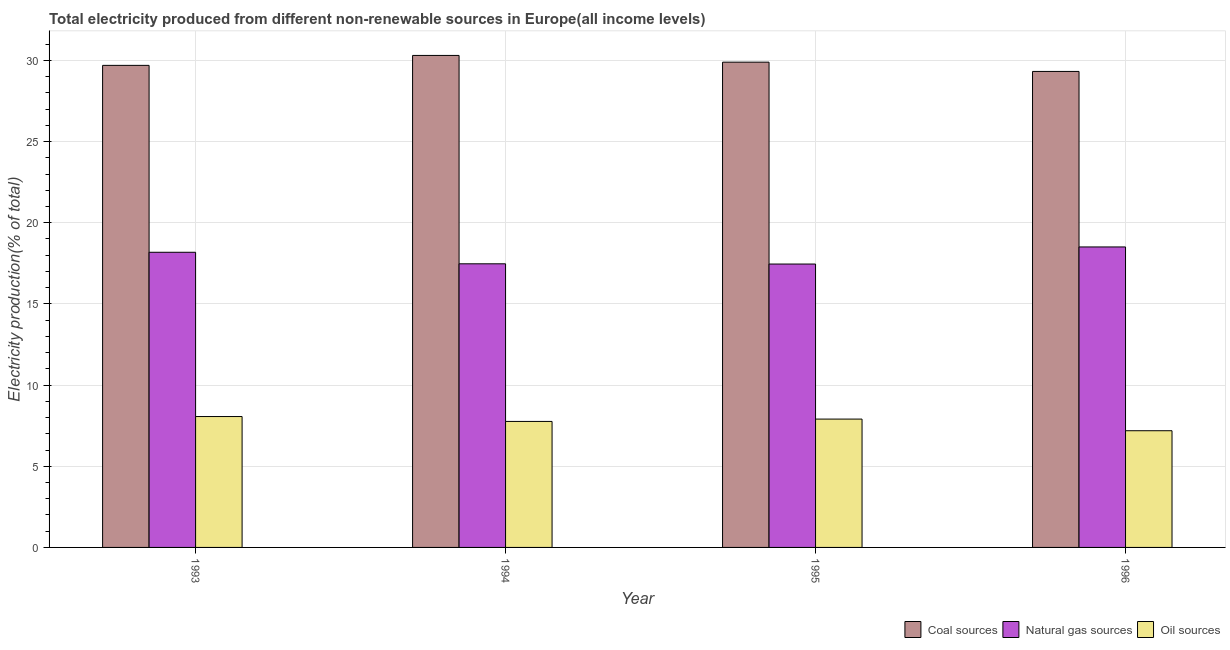How many different coloured bars are there?
Give a very brief answer. 3. How many bars are there on the 2nd tick from the left?
Provide a short and direct response. 3. What is the percentage of electricity produced by coal in 1993?
Keep it short and to the point. 29.7. Across all years, what is the maximum percentage of electricity produced by natural gas?
Offer a terse response. 18.51. Across all years, what is the minimum percentage of electricity produced by oil sources?
Give a very brief answer. 7.19. In which year was the percentage of electricity produced by coal minimum?
Provide a short and direct response. 1996. What is the total percentage of electricity produced by oil sources in the graph?
Your answer should be compact. 30.92. What is the difference between the percentage of electricity produced by oil sources in 1993 and that in 1995?
Give a very brief answer. 0.16. What is the difference between the percentage of electricity produced by natural gas in 1996 and the percentage of electricity produced by coal in 1993?
Provide a succinct answer. 0.33. What is the average percentage of electricity produced by natural gas per year?
Ensure brevity in your answer.  17.9. In the year 1996, what is the difference between the percentage of electricity produced by oil sources and percentage of electricity produced by coal?
Your answer should be very brief. 0. What is the ratio of the percentage of electricity produced by coal in 1994 to that in 1996?
Offer a very short reply. 1.03. What is the difference between the highest and the second highest percentage of electricity produced by oil sources?
Your answer should be very brief. 0.16. What is the difference between the highest and the lowest percentage of electricity produced by oil sources?
Keep it short and to the point. 0.87. What does the 1st bar from the left in 1996 represents?
Ensure brevity in your answer.  Coal sources. What does the 2nd bar from the right in 1996 represents?
Your answer should be very brief. Natural gas sources. How many bars are there?
Your response must be concise. 12. What is the difference between two consecutive major ticks on the Y-axis?
Your response must be concise. 5. Does the graph contain any zero values?
Your answer should be compact. No. Where does the legend appear in the graph?
Offer a terse response. Bottom right. What is the title of the graph?
Ensure brevity in your answer.  Total electricity produced from different non-renewable sources in Europe(all income levels). What is the label or title of the Y-axis?
Provide a succinct answer. Electricity production(% of total). What is the Electricity production(% of total) in Coal sources in 1993?
Give a very brief answer. 29.7. What is the Electricity production(% of total) of Natural gas sources in 1993?
Provide a short and direct response. 18.18. What is the Electricity production(% of total) of Oil sources in 1993?
Your answer should be very brief. 8.06. What is the Electricity production(% of total) of Coal sources in 1994?
Ensure brevity in your answer.  30.31. What is the Electricity production(% of total) of Natural gas sources in 1994?
Your response must be concise. 17.47. What is the Electricity production(% of total) in Oil sources in 1994?
Offer a very short reply. 7.76. What is the Electricity production(% of total) in Coal sources in 1995?
Ensure brevity in your answer.  29.89. What is the Electricity production(% of total) of Natural gas sources in 1995?
Provide a short and direct response. 17.46. What is the Electricity production(% of total) of Oil sources in 1995?
Make the answer very short. 7.91. What is the Electricity production(% of total) of Coal sources in 1996?
Keep it short and to the point. 29.32. What is the Electricity production(% of total) of Natural gas sources in 1996?
Offer a very short reply. 18.51. What is the Electricity production(% of total) of Oil sources in 1996?
Provide a succinct answer. 7.19. Across all years, what is the maximum Electricity production(% of total) of Coal sources?
Offer a terse response. 30.31. Across all years, what is the maximum Electricity production(% of total) of Natural gas sources?
Ensure brevity in your answer.  18.51. Across all years, what is the maximum Electricity production(% of total) in Oil sources?
Give a very brief answer. 8.06. Across all years, what is the minimum Electricity production(% of total) in Coal sources?
Offer a very short reply. 29.32. Across all years, what is the minimum Electricity production(% of total) in Natural gas sources?
Your answer should be very brief. 17.46. Across all years, what is the minimum Electricity production(% of total) of Oil sources?
Provide a succinct answer. 7.19. What is the total Electricity production(% of total) in Coal sources in the graph?
Make the answer very short. 119.22. What is the total Electricity production(% of total) of Natural gas sources in the graph?
Provide a short and direct response. 71.62. What is the total Electricity production(% of total) of Oil sources in the graph?
Ensure brevity in your answer.  30.92. What is the difference between the Electricity production(% of total) in Coal sources in 1993 and that in 1994?
Keep it short and to the point. -0.61. What is the difference between the Electricity production(% of total) in Natural gas sources in 1993 and that in 1994?
Provide a short and direct response. 0.71. What is the difference between the Electricity production(% of total) of Oil sources in 1993 and that in 1994?
Provide a short and direct response. 0.3. What is the difference between the Electricity production(% of total) of Coal sources in 1993 and that in 1995?
Make the answer very short. -0.2. What is the difference between the Electricity production(% of total) of Natural gas sources in 1993 and that in 1995?
Offer a terse response. 0.72. What is the difference between the Electricity production(% of total) in Oil sources in 1993 and that in 1995?
Ensure brevity in your answer.  0.16. What is the difference between the Electricity production(% of total) in Coal sources in 1993 and that in 1996?
Provide a succinct answer. 0.37. What is the difference between the Electricity production(% of total) in Natural gas sources in 1993 and that in 1996?
Give a very brief answer. -0.33. What is the difference between the Electricity production(% of total) in Oil sources in 1993 and that in 1996?
Ensure brevity in your answer.  0.87. What is the difference between the Electricity production(% of total) in Coal sources in 1994 and that in 1995?
Provide a succinct answer. 0.41. What is the difference between the Electricity production(% of total) of Natural gas sources in 1994 and that in 1995?
Ensure brevity in your answer.  0.01. What is the difference between the Electricity production(% of total) of Oil sources in 1994 and that in 1995?
Your response must be concise. -0.14. What is the difference between the Electricity production(% of total) in Coal sources in 1994 and that in 1996?
Your answer should be compact. 0.99. What is the difference between the Electricity production(% of total) of Natural gas sources in 1994 and that in 1996?
Your response must be concise. -1.04. What is the difference between the Electricity production(% of total) of Oil sources in 1994 and that in 1996?
Keep it short and to the point. 0.57. What is the difference between the Electricity production(% of total) of Coal sources in 1995 and that in 1996?
Provide a succinct answer. 0.57. What is the difference between the Electricity production(% of total) in Natural gas sources in 1995 and that in 1996?
Your response must be concise. -1.05. What is the difference between the Electricity production(% of total) in Oil sources in 1995 and that in 1996?
Keep it short and to the point. 0.72. What is the difference between the Electricity production(% of total) in Coal sources in 1993 and the Electricity production(% of total) in Natural gas sources in 1994?
Provide a short and direct response. 12.22. What is the difference between the Electricity production(% of total) of Coal sources in 1993 and the Electricity production(% of total) of Oil sources in 1994?
Give a very brief answer. 21.93. What is the difference between the Electricity production(% of total) in Natural gas sources in 1993 and the Electricity production(% of total) in Oil sources in 1994?
Provide a short and direct response. 10.42. What is the difference between the Electricity production(% of total) in Coal sources in 1993 and the Electricity production(% of total) in Natural gas sources in 1995?
Make the answer very short. 12.24. What is the difference between the Electricity production(% of total) of Coal sources in 1993 and the Electricity production(% of total) of Oil sources in 1995?
Your answer should be very brief. 21.79. What is the difference between the Electricity production(% of total) of Natural gas sources in 1993 and the Electricity production(% of total) of Oil sources in 1995?
Provide a short and direct response. 10.28. What is the difference between the Electricity production(% of total) in Coal sources in 1993 and the Electricity production(% of total) in Natural gas sources in 1996?
Your answer should be compact. 11.19. What is the difference between the Electricity production(% of total) of Coal sources in 1993 and the Electricity production(% of total) of Oil sources in 1996?
Provide a succinct answer. 22.51. What is the difference between the Electricity production(% of total) in Natural gas sources in 1993 and the Electricity production(% of total) in Oil sources in 1996?
Provide a short and direct response. 10.99. What is the difference between the Electricity production(% of total) of Coal sources in 1994 and the Electricity production(% of total) of Natural gas sources in 1995?
Offer a terse response. 12.85. What is the difference between the Electricity production(% of total) in Coal sources in 1994 and the Electricity production(% of total) in Oil sources in 1995?
Keep it short and to the point. 22.4. What is the difference between the Electricity production(% of total) of Natural gas sources in 1994 and the Electricity production(% of total) of Oil sources in 1995?
Offer a very short reply. 9.56. What is the difference between the Electricity production(% of total) in Coal sources in 1994 and the Electricity production(% of total) in Natural gas sources in 1996?
Provide a succinct answer. 11.8. What is the difference between the Electricity production(% of total) in Coal sources in 1994 and the Electricity production(% of total) in Oil sources in 1996?
Provide a short and direct response. 23.12. What is the difference between the Electricity production(% of total) in Natural gas sources in 1994 and the Electricity production(% of total) in Oil sources in 1996?
Offer a terse response. 10.28. What is the difference between the Electricity production(% of total) in Coal sources in 1995 and the Electricity production(% of total) in Natural gas sources in 1996?
Keep it short and to the point. 11.38. What is the difference between the Electricity production(% of total) of Coal sources in 1995 and the Electricity production(% of total) of Oil sources in 1996?
Provide a short and direct response. 22.7. What is the difference between the Electricity production(% of total) in Natural gas sources in 1995 and the Electricity production(% of total) in Oil sources in 1996?
Your answer should be very brief. 10.27. What is the average Electricity production(% of total) in Coal sources per year?
Keep it short and to the point. 29.8. What is the average Electricity production(% of total) in Natural gas sources per year?
Your answer should be very brief. 17.91. What is the average Electricity production(% of total) in Oil sources per year?
Offer a very short reply. 7.73. In the year 1993, what is the difference between the Electricity production(% of total) of Coal sources and Electricity production(% of total) of Natural gas sources?
Provide a succinct answer. 11.51. In the year 1993, what is the difference between the Electricity production(% of total) of Coal sources and Electricity production(% of total) of Oil sources?
Your response must be concise. 21.63. In the year 1993, what is the difference between the Electricity production(% of total) in Natural gas sources and Electricity production(% of total) in Oil sources?
Provide a short and direct response. 10.12. In the year 1994, what is the difference between the Electricity production(% of total) in Coal sources and Electricity production(% of total) in Natural gas sources?
Your answer should be compact. 12.84. In the year 1994, what is the difference between the Electricity production(% of total) of Coal sources and Electricity production(% of total) of Oil sources?
Keep it short and to the point. 22.55. In the year 1994, what is the difference between the Electricity production(% of total) in Natural gas sources and Electricity production(% of total) in Oil sources?
Your answer should be compact. 9.71. In the year 1995, what is the difference between the Electricity production(% of total) in Coal sources and Electricity production(% of total) in Natural gas sources?
Ensure brevity in your answer.  12.44. In the year 1995, what is the difference between the Electricity production(% of total) in Coal sources and Electricity production(% of total) in Oil sources?
Give a very brief answer. 21.99. In the year 1995, what is the difference between the Electricity production(% of total) of Natural gas sources and Electricity production(% of total) of Oil sources?
Make the answer very short. 9.55. In the year 1996, what is the difference between the Electricity production(% of total) in Coal sources and Electricity production(% of total) in Natural gas sources?
Provide a short and direct response. 10.81. In the year 1996, what is the difference between the Electricity production(% of total) in Coal sources and Electricity production(% of total) in Oil sources?
Make the answer very short. 22.13. In the year 1996, what is the difference between the Electricity production(% of total) in Natural gas sources and Electricity production(% of total) in Oil sources?
Make the answer very short. 11.32. What is the ratio of the Electricity production(% of total) in Coal sources in 1993 to that in 1994?
Offer a very short reply. 0.98. What is the ratio of the Electricity production(% of total) of Natural gas sources in 1993 to that in 1994?
Offer a terse response. 1.04. What is the ratio of the Electricity production(% of total) of Oil sources in 1993 to that in 1994?
Offer a very short reply. 1.04. What is the ratio of the Electricity production(% of total) in Coal sources in 1993 to that in 1995?
Offer a terse response. 0.99. What is the ratio of the Electricity production(% of total) in Natural gas sources in 1993 to that in 1995?
Provide a succinct answer. 1.04. What is the ratio of the Electricity production(% of total) of Oil sources in 1993 to that in 1995?
Offer a very short reply. 1.02. What is the ratio of the Electricity production(% of total) in Coal sources in 1993 to that in 1996?
Provide a succinct answer. 1.01. What is the ratio of the Electricity production(% of total) of Natural gas sources in 1993 to that in 1996?
Provide a short and direct response. 0.98. What is the ratio of the Electricity production(% of total) of Oil sources in 1993 to that in 1996?
Provide a short and direct response. 1.12. What is the ratio of the Electricity production(% of total) of Coal sources in 1994 to that in 1995?
Your response must be concise. 1.01. What is the ratio of the Electricity production(% of total) in Oil sources in 1994 to that in 1995?
Offer a terse response. 0.98. What is the ratio of the Electricity production(% of total) of Coal sources in 1994 to that in 1996?
Make the answer very short. 1.03. What is the ratio of the Electricity production(% of total) in Natural gas sources in 1994 to that in 1996?
Offer a very short reply. 0.94. What is the ratio of the Electricity production(% of total) of Oil sources in 1994 to that in 1996?
Make the answer very short. 1.08. What is the ratio of the Electricity production(% of total) in Coal sources in 1995 to that in 1996?
Give a very brief answer. 1.02. What is the ratio of the Electricity production(% of total) in Natural gas sources in 1995 to that in 1996?
Offer a terse response. 0.94. What is the ratio of the Electricity production(% of total) in Oil sources in 1995 to that in 1996?
Provide a short and direct response. 1.1. What is the difference between the highest and the second highest Electricity production(% of total) in Coal sources?
Ensure brevity in your answer.  0.41. What is the difference between the highest and the second highest Electricity production(% of total) in Natural gas sources?
Offer a very short reply. 0.33. What is the difference between the highest and the second highest Electricity production(% of total) in Oil sources?
Give a very brief answer. 0.16. What is the difference between the highest and the lowest Electricity production(% of total) of Coal sources?
Your answer should be compact. 0.99. What is the difference between the highest and the lowest Electricity production(% of total) of Natural gas sources?
Your answer should be very brief. 1.05. What is the difference between the highest and the lowest Electricity production(% of total) in Oil sources?
Keep it short and to the point. 0.87. 